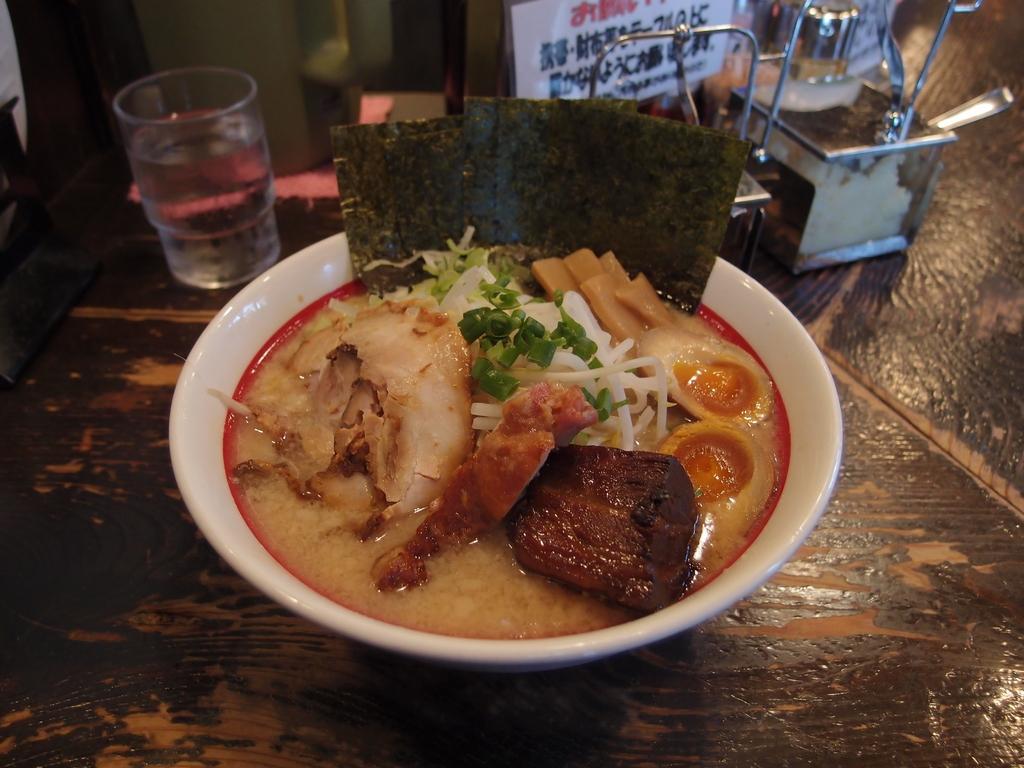Please provide a concise description of this image. In the center of the image there is a table. On the table we can see bowl of food item, glass of water, spoons, some vessels. 